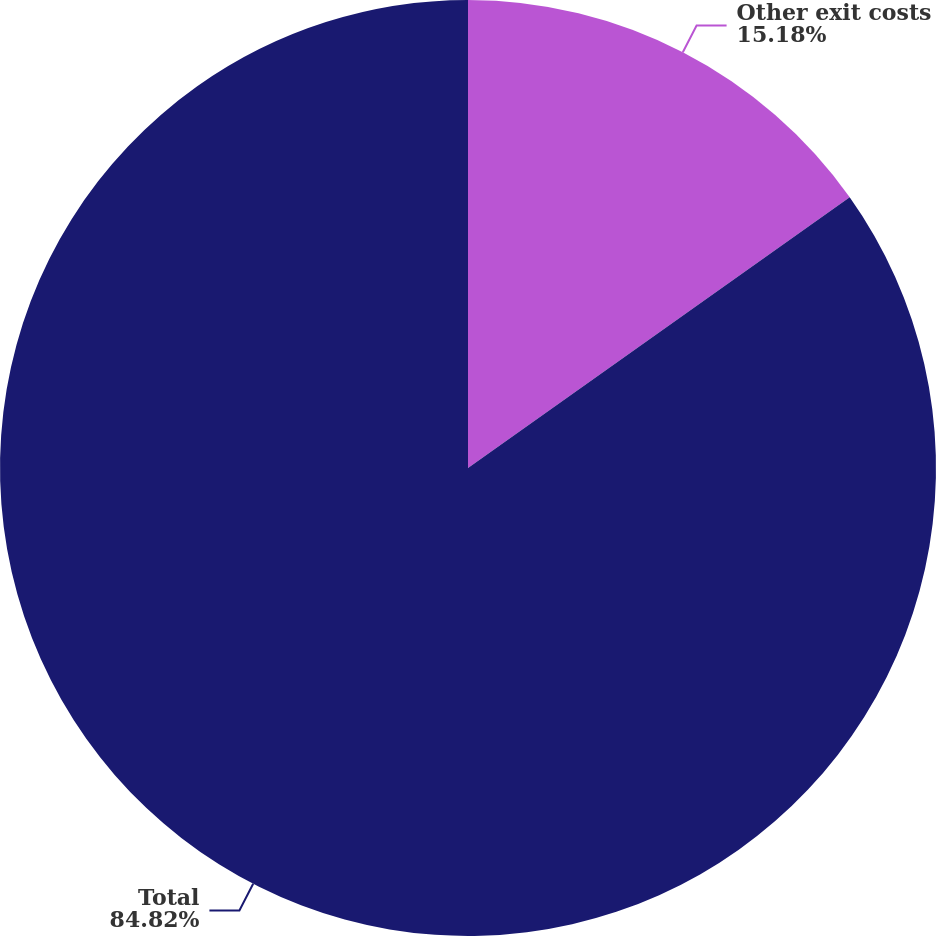Convert chart. <chart><loc_0><loc_0><loc_500><loc_500><pie_chart><fcel>Other exit costs<fcel>Total<nl><fcel>15.18%<fcel>84.82%<nl></chart> 